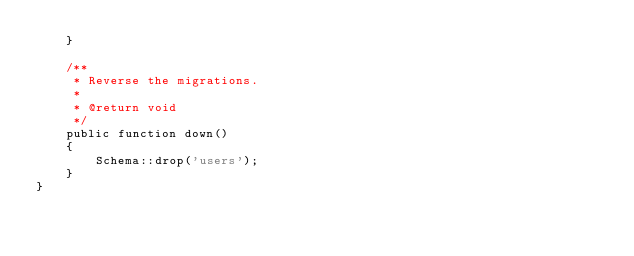Convert code to text. <code><loc_0><loc_0><loc_500><loc_500><_PHP_>    }

    /**
     * Reverse the migrations.
     *
     * @return void
     */
    public function down()
    {
        Schema::drop('users');
    }
}
</code> 